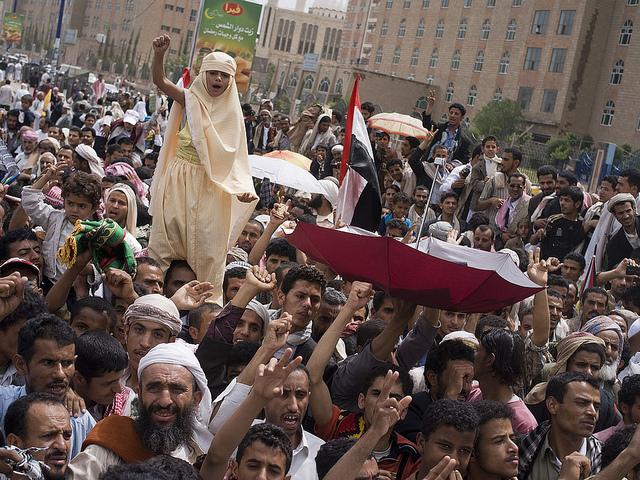What are the people holding above their heads?
Short answer required. Umbrella. How many people are wearing white?
Quick response, please. Many. How many people are in the picture?
Write a very short answer. Many. 